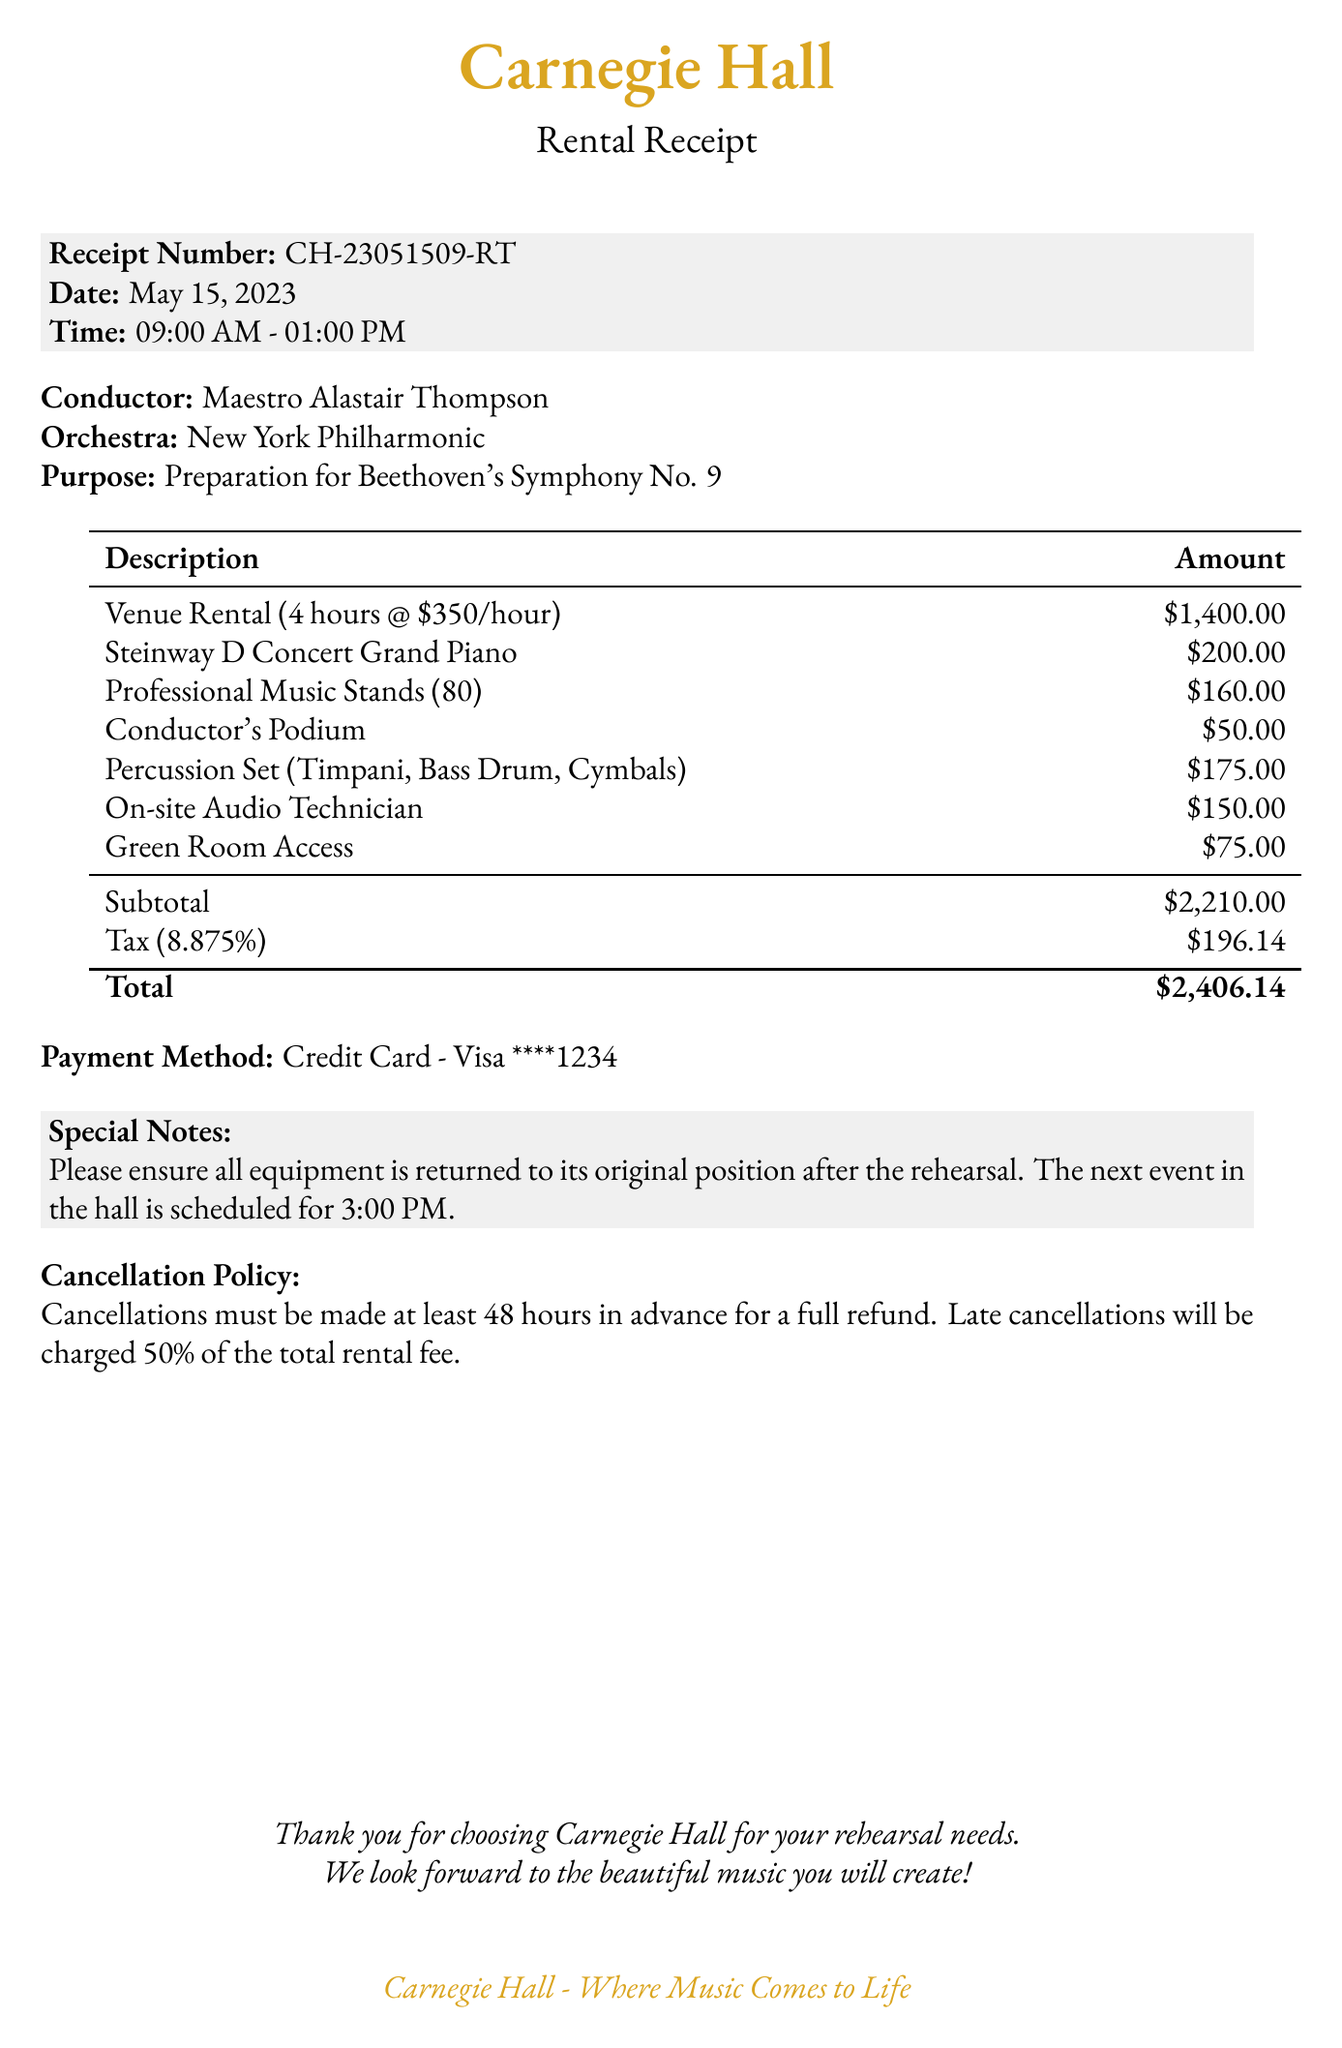What is the venue name? The venue name is stated at the beginning of the document.
Answer: Carnegie Hall What is the rental date? The rental date is clearly listed near the top of the receipt.
Answer: May 15, 2023 How many hours was the rental for? The duration of the rental is mentioned in hours within the document.
Answer: 4 What was the hourly rate for the rental? The hourly rate is specified in the rental description section.
Answer: 350 What is the total amount due? The total amount is stated at the bottom of the receipt, after calculating the subtotal and tax.
Answer: 2406.14 What is the fee for the Steinway D Concert Grand Piano? The specific fee for the piano is listed in the equipment fees section.
Answer: 200 What is the cancellation policy regarding refunds? The document mentions the conditions for cancellations related to refunds.
Answer: 48 hours What additional service has a fee of 150? The additional services are listed with their respective fees in the document.
Answer: On-site Audio Technician What should be done with the equipment after the rehearsal? The special notes section contains instructions regarding equipment handling.
Answer: Returned to its original position 